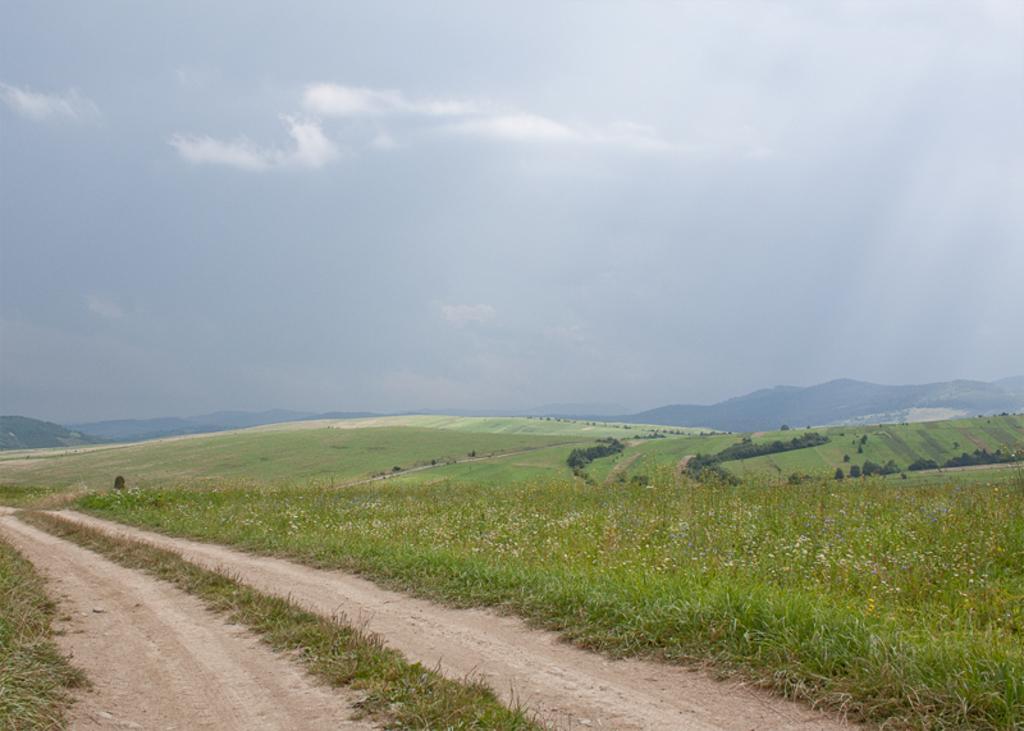Please provide a concise description of this image. In this image we can see the road, grasslands, trees, hills and the sky with clouds in the background. 